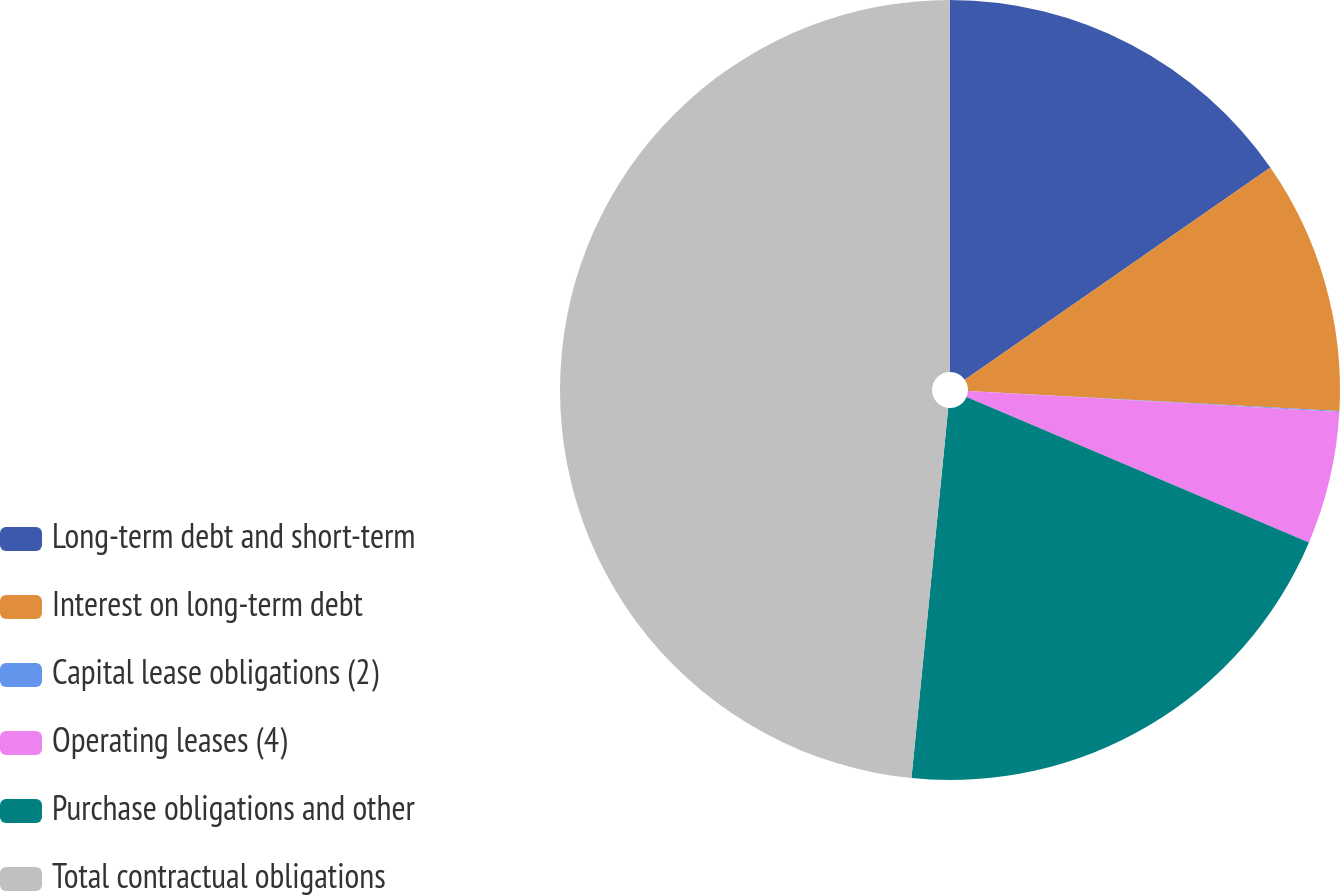Convert chart to OTSL. <chart><loc_0><loc_0><loc_500><loc_500><pie_chart><fcel>Long-term debt and short-term<fcel>Interest on long-term debt<fcel>Capital lease obligations (2)<fcel>Operating leases (4)<fcel>Purchase obligations and other<fcel>Total contractual obligations<nl><fcel>15.34%<fcel>10.51%<fcel>0.05%<fcel>5.49%<fcel>20.18%<fcel>48.42%<nl></chart> 